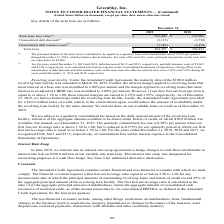According to Greensky's financial document, How is the principal balance of the term loan scheduled to be repaid? on a quarterly basis at an amortization rate of 0.25% per quarter through December 31, 2024, with the balance due at maturity.. The document states: "balance of the term loan is scheduled to be repaid on a quarterly basis at an amortization rate of 0.25% per quarter through December 31, 2024, with t..." Also, What was the unamortized debt discount in 2018? According to the financial document, (3,728) (in thousands). The relevant text states: "00 $ 397,000 Unamortized debt discount (2) (3,115) (3,728) Unamortized debt issuance costs (2) (5,388) (6,450) Term loan $ 384,497 $ 386,822..." Also, Which years does the table provide information for Key details of the term loan? The document shows two values: 2019 and 2018. From the document: "December 31, 2019 2018 Term loan, face value (1) $ 393,000 $ 397,000 Unamortized debt discount (2) (3,115) (3,728) Un December 31, 2019 2018 Term loan..." Also, How many years did the face value of term loan exceed $300,000 thousand? Counting the relevant items in the document: 2019, 2018, I find 2 instances. The key data points involved are: 2018, 2019. Also, can you calculate: What was the change in the Unamortized debt discount between 2018 and 2019? Based on the calculation: -3,115-(-3,728), the result is 613 (in thousands). This is based on the information: "$ 397,000 Unamortized debt discount (2) (3,115) (3,728) Unamortized debt issuance costs (2) (5,388) (6,450) Term loan $ 384,497 $ 386,822 393,000 $ 397,000 Unamortized debt discount (2) (3,115) (3,728..." The key data points involved are: 3,115, 3,728. Also, can you calculate: What was the percentage change in the term loan between 2018 and 2019? To answer this question, I need to perform calculations using the financial data. The calculation is: (384,497-386,822)/386,822, which equals -0.6 (percentage). This is based on the information: "bt issuance costs (2) (5,388) (6,450) Term loan $ 384,497 $ 386,822 e costs (2) (5,388) (6,450) Term loan $ 384,497 $ 386,822..." The key data points involved are: 384,497, 386,822. 